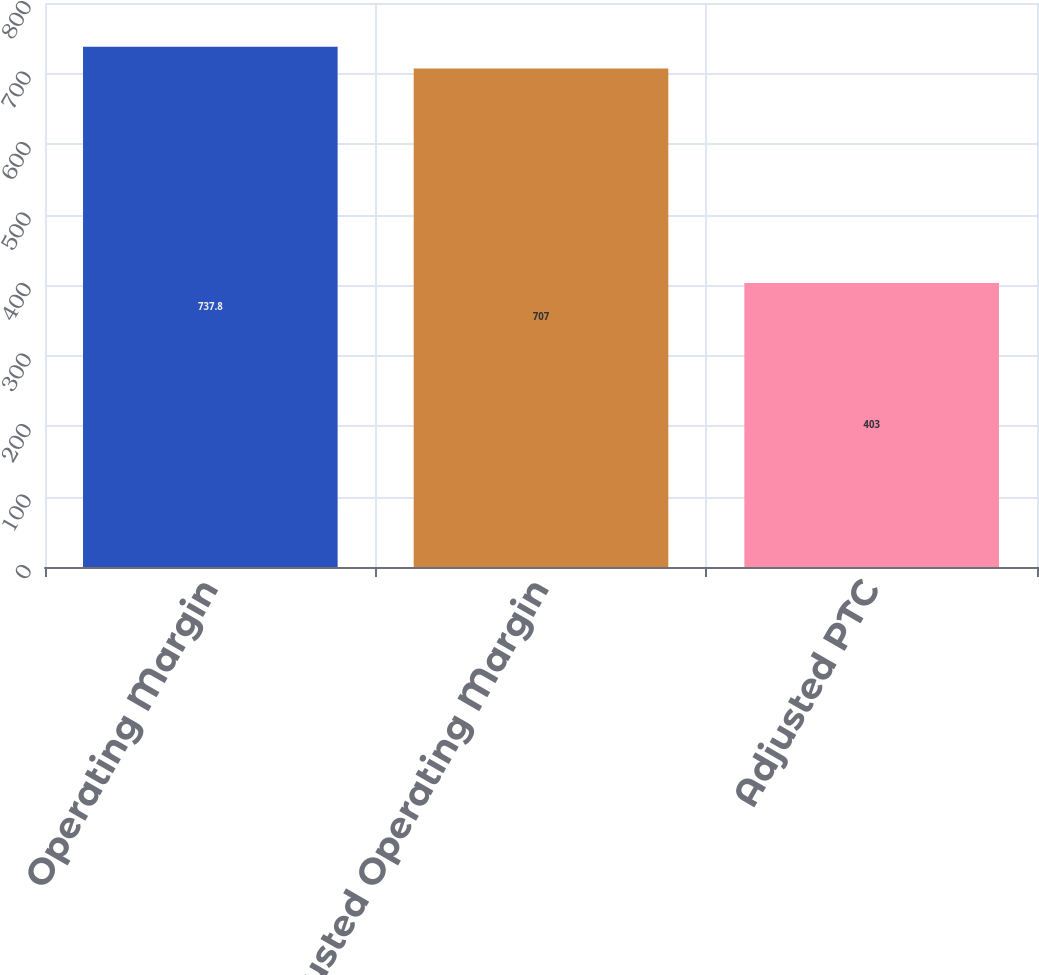Convert chart. <chart><loc_0><loc_0><loc_500><loc_500><bar_chart><fcel>Operating Margin<fcel>Adjusted Operating Margin<fcel>Adjusted PTC<nl><fcel>737.8<fcel>707<fcel>403<nl></chart> 